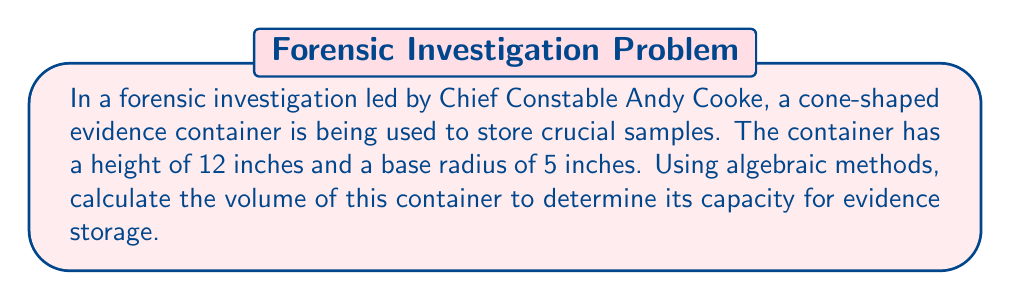Can you solve this math problem? Let's approach this step-by-step using algebraic methods:

1) The volume of a cone is given by the formula:

   $$V = \frac{1}{3}\pi r^2 h$$

   Where $V$ is volume, $r$ is the radius of the base, and $h$ is the height.

2) We are given:
   $r = 5$ inches
   $h = 12$ inches

3) Let's substitute these values into our formula:

   $$V = \frac{1}{3}\pi (5^2) (12)$$

4) Simplify the expression inside the parentheses:

   $$V = \frac{1}{3}\pi (25) (12)$$

5) Multiply the numbers:

   $$V = \frac{1}{3}\pi (300)$$

6) Simplify:

   $$V = 100\pi$$

7) If we need a decimal approximation, we can calculate:

   $$V \approx 314.16$$

Therefore, the volume of the cone-shaped evidence container is $100\pi$ cubic inches, or approximately 314.16 cubic inches.
Answer: $100\pi$ cubic inches 